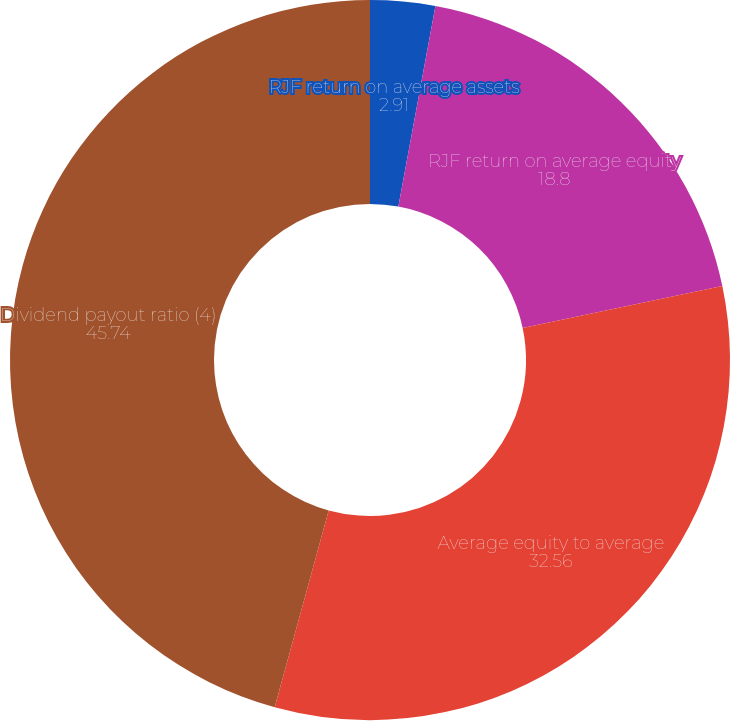Convert chart to OTSL. <chart><loc_0><loc_0><loc_500><loc_500><pie_chart><fcel>RJF return on average assets<fcel>RJF return on average equity<fcel>Average equity to average<fcel>Dividend payout ratio (4)<nl><fcel>2.91%<fcel>18.8%<fcel>32.56%<fcel>45.74%<nl></chart> 